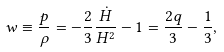Convert formula to latex. <formula><loc_0><loc_0><loc_500><loc_500>w \equiv \frac { p } { \rho } = - \frac { 2 } { 3 } \frac { \dot { H } } { H ^ { 2 } } - 1 = \frac { 2 q } { 3 } - \frac { 1 } { 3 } ,</formula> 